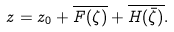<formula> <loc_0><loc_0><loc_500><loc_500>z = z _ { 0 } + \overline { F ( { \zeta } ) } + \overline { H ( \bar { \zeta } ) } .</formula> 